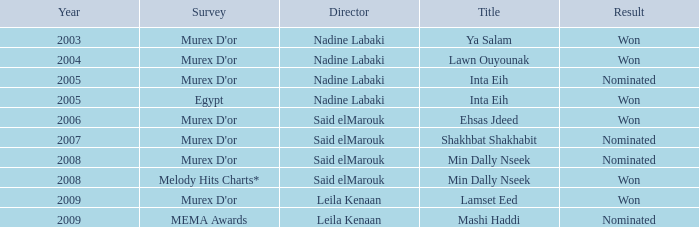What is the result for director Said Elmarouk before 2008? Won, Nominated. 